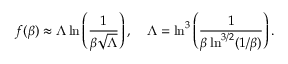Convert formula to latex. <formula><loc_0><loc_0><loc_500><loc_500>f ( \beta ) \approx \Lambda \ln \left ( \frac { 1 } { \beta \sqrt { \Lambda } } \right ) , \quad \Lambda = \ln ^ { 3 } \left ( \frac { 1 } { \beta \ln ^ { 3 / 2 } ( 1 / \beta ) } \right ) .</formula> 